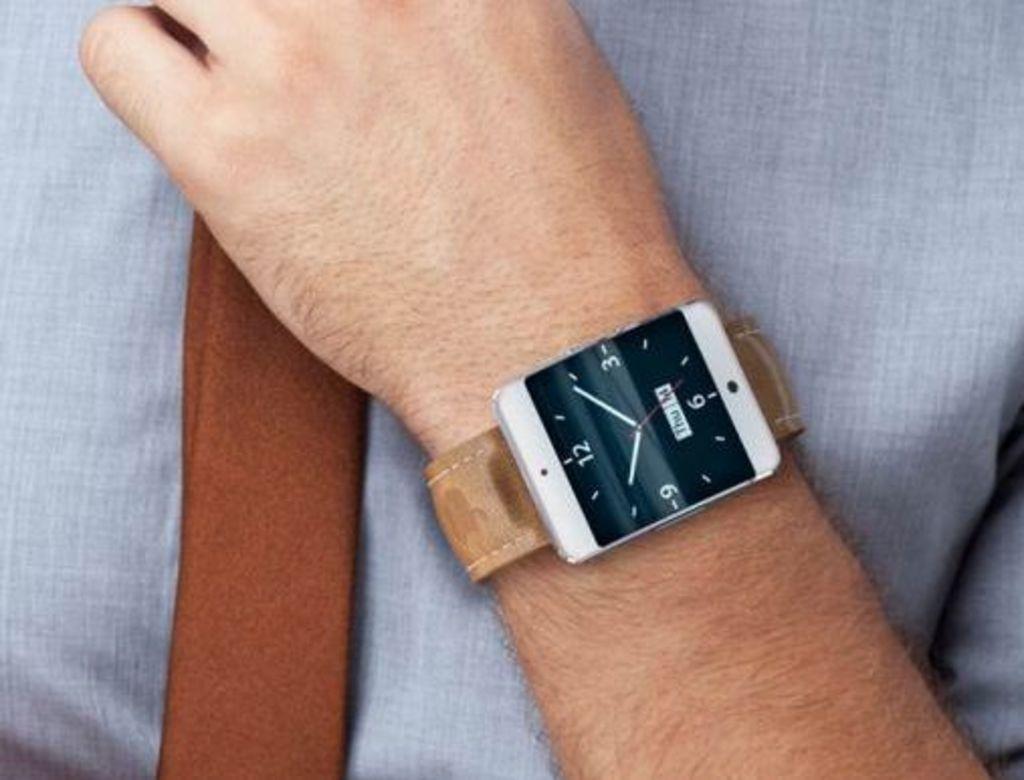What time does the watch show?
Your answer should be compact. 10:09. What time does the watch not show?
Make the answer very short. 10:09. 